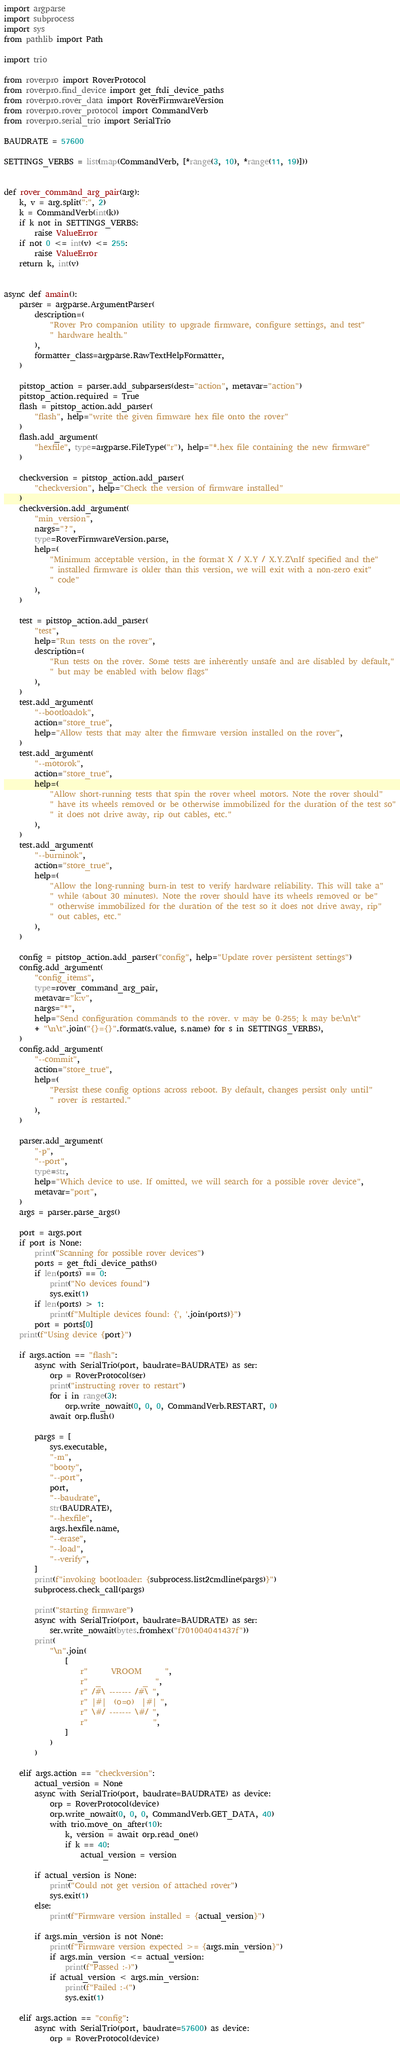Convert code to text. <code><loc_0><loc_0><loc_500><loc_500><_Python_>import argparse
import subprocess
import sys
from pathlib import Path

import trio

from roverpro import RoverProtocol
from roverpro.find_device import get_ftdi_device_paths
from roverpro.rover_data import RoverFirmwareVersion
from roverpro.rover_protocol import CommandVerb
from roverpro.serial_trio import SerialTrio

BAUDRATE = 57600

SETTINGS_VERBS = list(map(CommandVerb, [*range(3, 10), *range(11, 19)]))


def rover_command_arg_pair(arg):
    k, v = arg.split(":", 2)
    k = CommandVerb(int(k))
    if k not in SETTINGS_VERBS:
        raise ValueError
    if not 0 <= int(v) <= 255:
        raise ValueError
    return k, int(v)


async def amain():
    parser = argparse.ArgumentParser(
        description=(
            "Rover Pro companion utility to upgrade firmware, configure settings, and test"
            " hardware health."
        ),
        formatter_class=argparse.RawTextHelpFormatter,
    )

    pitstop_action = parser.add_subparsers(dest="action", metavar="action")
    pitstop_action.required = True
    flash = pitstop_action.add_parser(
        "flash", help="write the given firmware hex file onto the rover"
    )
    flash.add_argument(
        "hexfile", type=argparse.FileType("r"), help="*.hex file containing the new firmware"
    )

    checkversion = pitstop_action.add_parser(
        "checkversion", help="Check the version of firmware installed"
    )
    checkversion.add_argument(
        "min_version",
        nargs="?",
        type=RoverFirmwareVersion.parse,
        help=(
            "Minimum acceptable version, in the format X / X.Y / X.Y.Z\nIf specified and the"
            " installed firmware is older than this version, we will exit with a non-zero exit"
            " code"
        ),
    )

    test = pitstop_action.add_parser(
        "test",
        help="Run tests on the rover",
        description=(
            "Run tests on the rover. Some tests are inherently unsafe and are disabled by default,"
            " but may be enabled with below flags"
        ),
    )
    test.add_argument(
        "--bootloadok",
        action="store_true",
        help="Allow tests that may alter the firmware version installed on the rover",
    )
    test.add_argument(
        "--motorok",
        action="store_true",
        help=(
            "Allow short-running tests that spin the rover wheel motors. Note the rover should"
            " have its wheels removed or be otherwise immobilized for the duration of the test so"
            " it does not drive away, rip out cables, etc."
        ),
    )
    test.add_argument(
        "--burninok",
        action="store_true",
        help=(
            "Allow the long-running burn-in test to verify hardware reliability. This will take a"
            " while (about 30 minutes). Note the rover should have its wheels removed or be"
            " otherwise immobilized for the duration of the test so it does not drive away, rip"
            " out cables, etc."
        ),
    )

    config = pitstop_action.add_parser("config", help="Update rover persistent settings")
    config.add_argument(
        "config_items",
        type=rover_command_arg_pair,
        metavar="k:v",
        nargs="*",
        help="Send configuration commands to the rover. v may be 0-255; k may be:\n\t"
        + "\n\t".join("{}={}".format(s.value, s.name) for s in SETTINGS_VERBS),
    )
    config.add_argument(
        "--commit",
        action="store_true",
        help=(
            "Persist these config options across reboot. By default, changes persist only until"
            " rover is restarted."
        ),
    )

    parser.add_argument(
        "-p",
        "--port",
        type=str,
        help="Which device to use. If omitted, we will search for a possible rover device",
        metavar="port",
    )
    args = parser.parse_args()

    port = args.port
    if port is None:
        print("Scanning for possible rover devices")
        ports = get_ftdi_device_paths()
        if len(ports) == 0:
            print("No devices found")
            sys.exit(1)
        if len(ports) > 1:
            print(f"Multiple devices found: {', '.join(ports)}")
        port = ports[0]
    print(f"Using device {port}")

    if args.action == "flash":
        async with SerialTrio(port, baudrate=BAUDRATE) as ser:
            orp = RoverProtocol(ser)
            print("instructing rover to restart")
            for i in range(3):
                orp.write_nowait(0, 0, 0, CommandVerb.RESTART, 0)
            await orp.flush()

        pargs = [
            sys.executable,
            "-m",
            "booty",
            "--port",
            port,
            "--baudrate",
            str(BAUDRATE),
            "--hexfile",
            args.hexfile.name,
            "--erase",
            "--load",
            "--verify",
        ]
        print(f"invoking bootloader: {subprocess.list2cmdline(pargs)}")
        subprocess.check_call(pargs)

        print("starting firmware")
        async with SerialTrio(port, baudrate=BAUDRATE) as ser:
            ser.write_nowait(bytes.fromhex("f701004041437f"))
        print(
            "\n".join(
                [
                    r"      VROOM      ",
                    r"  _           _  ",
                    r" /#\ ------- /#\ ",
                    r" |#|  (o=o)  |#| ",
                    r" \#/ ------- \#/ ",
                    r"                 ",
                ]
            )
        )

    elif args.action == "checkversion":
        actual_version = None
        async with SerialTrio(port, baudrate=BAUDRATE) as device:
            orp = RoverProtocol(device)
            orp.write_nowait(0, 0, 0, CommandVerb.GET_DATA, 40)
            with trio.move_on_after(10):
                k, version = await orp.read_one()
                if k == 40:
                    actual_version = version

        if actual_version is None:
            print("Could not get version of attached rover")
            sys.exit(1)
        else:
            print(f"Firmware version installed = {actual_version}")

        if args.min_version is not None:
            print(f"Firmware version expected >= {args.min_version}")
            if args.min_version <= actual_version:
                print(f"Passed :-)")
            if actual_version < args.min_version:
                print(f"Failed :-(")
                sys.exit(1)

    elif args.action == "config":
        async with SerialTrio(port, baudrate=57600) as device:
            orp = RoverProtocol(device)</code> 